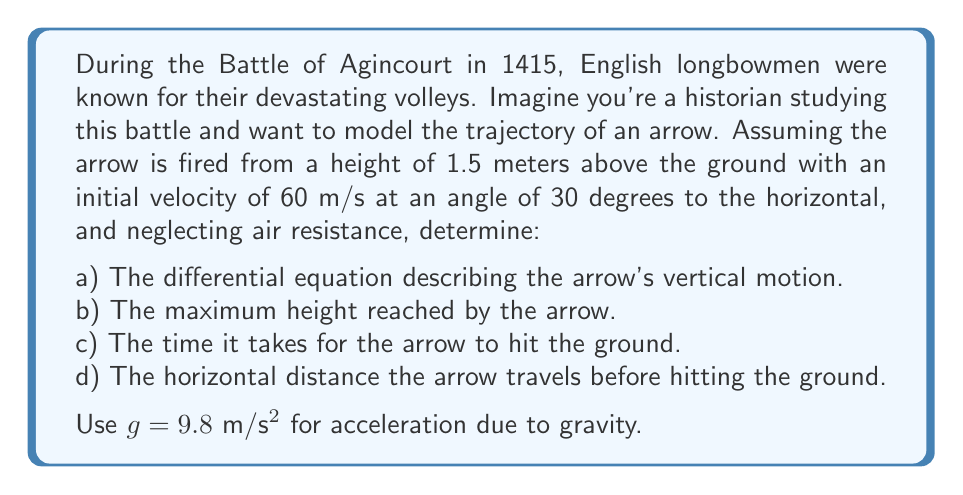Provide a solution to this math problem. Let's approach this problem step by step:

a) The differential equation describing the arrow's vertical motion:

The vertical motion of a projectile under gravity is described by a second-order differential equation:

$$\frac{d^2y}{dt^2} = -g$$

where $y$ is the vertical position and $t$ is time.

b) To find the maximum height:

First, we need to solve the differential equation. The general solution is:
$$y(t) = -\frac{1}{2}gt^2 + v_0\sin(\theta)t + y_0$$

Where $v_0 = 60$ m/s, $\theta = 30°$, and $y_0 = 1.5$ m.

The vertical component of the initial velocity is $v_0\sin(\theta) = 60 \sin(30°) = 30$ m/s.

So, our specific solution is:
$$y(t) = -4.9t^2 + 30t + 1.5$$

To find the maximum height, we need to find when the vertical velocity is zero:

$$\frac{dy}{dt} = -9.8t + 30 = 0$$
$$t = \frac{30}{9.8} \approx 3.06 \text{ seconds}$$

Plugging this back into our position equation:
$$y_{max} = -4.9(3.06)^2 + 30(3.06) + 1.5 \approx 47.24 \text{ meters}$$

c) Time to hit the ground:

We need to solve $y(t) = 0$:
$$-4.9t^2 + 30t + 1.5 = 0$$

This is a quadratic equation. Using the quadratic formula:
$$t = \frac{-b \pm \sqrt{b^2 - 4ac}}{2a}$$

Where $a = -4.9$, $b = 30$, and $c = 1.5$

$$t = \frac{-30 \pm \sqrt{900 + 29.4}}{-9.8} \approx 6.26 \text{ seconds}$$
(We take the positive root as time can't be negative)

d) Horizontal distance:

The horizontal motion is uniform with velocity $v_0\cos(\theta) = 60 \cos(30°) = 51.96$ m/s.

Distance = velocity × time
$$d = 51.96 \times 6.26 \approx 325.27 \text{ meters}$$
Answer: a) $\frac{d^2y}{dt^2} = -9.8$
b) 47.24 meters
c) 6.26 seconds
d) 325.27 meters 